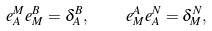<formula> <loc_0><loc_0><loc_500><loc_500>e ^ { M } _ { A } e ^ { B } _ { M } = \delta ^ { B } _ { A } , \quad e ^ { A } _ { M } e ^ { N } _ { A } = \delta ^ { N } _ { M } ,</formula> 